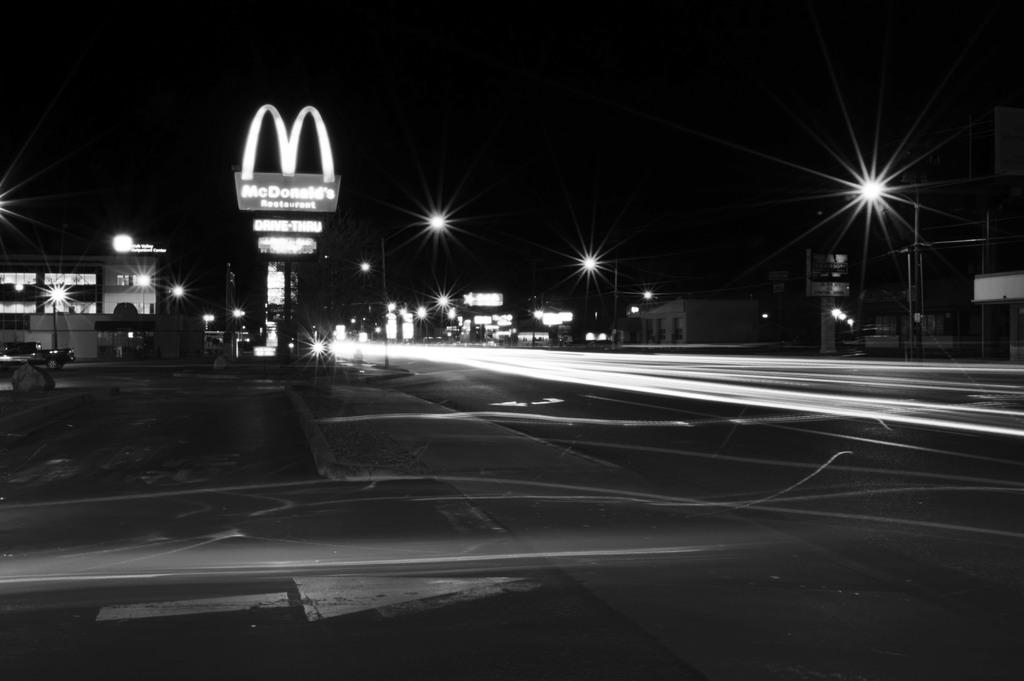What type of structures can be seen in the image? There are buildings in the image. What type of lighting is present in the image? Pole lights are present in the image. What type of signage is visible in the image? There are boards with text in the image. How would you describe the lighting conditions in the image? The background of the image is dark. What type of transportation is visible in the image? There is a vehicle on the road in the image. Can you tell me how many fairies are sitting on the dime in the image? There are no fairies or dimes present in the image. What type of season is depicted in the image? The provided facts do not mention any specific season, so it cannot be determined from the image. 